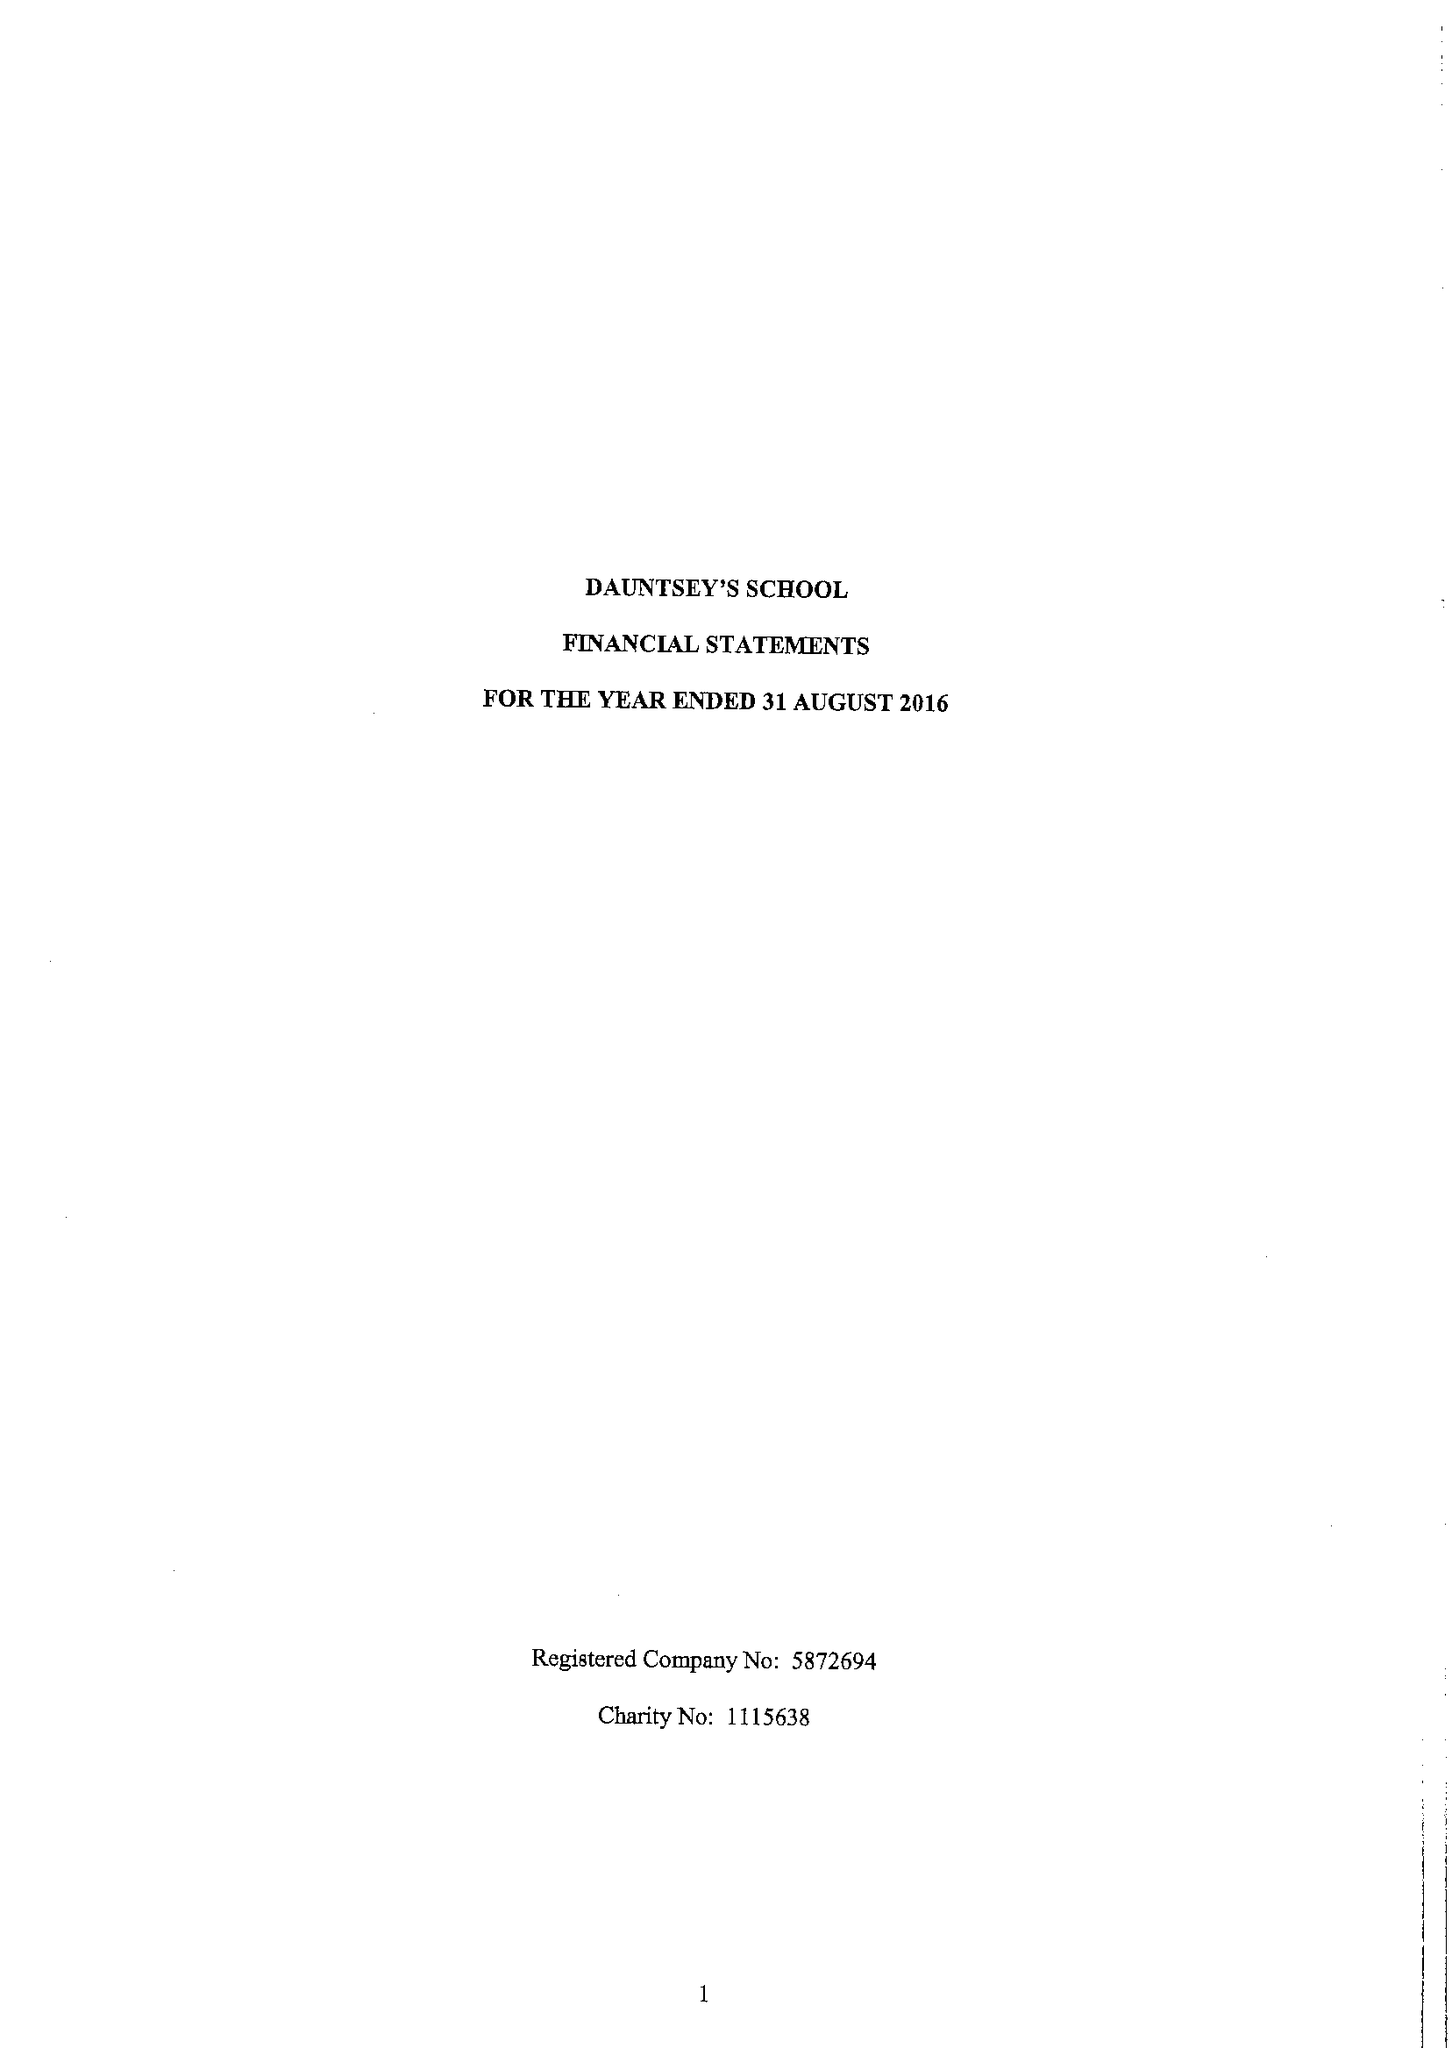What is the value for the address__post_town?
Answer the question using a single word or phrase. DEVIZES 